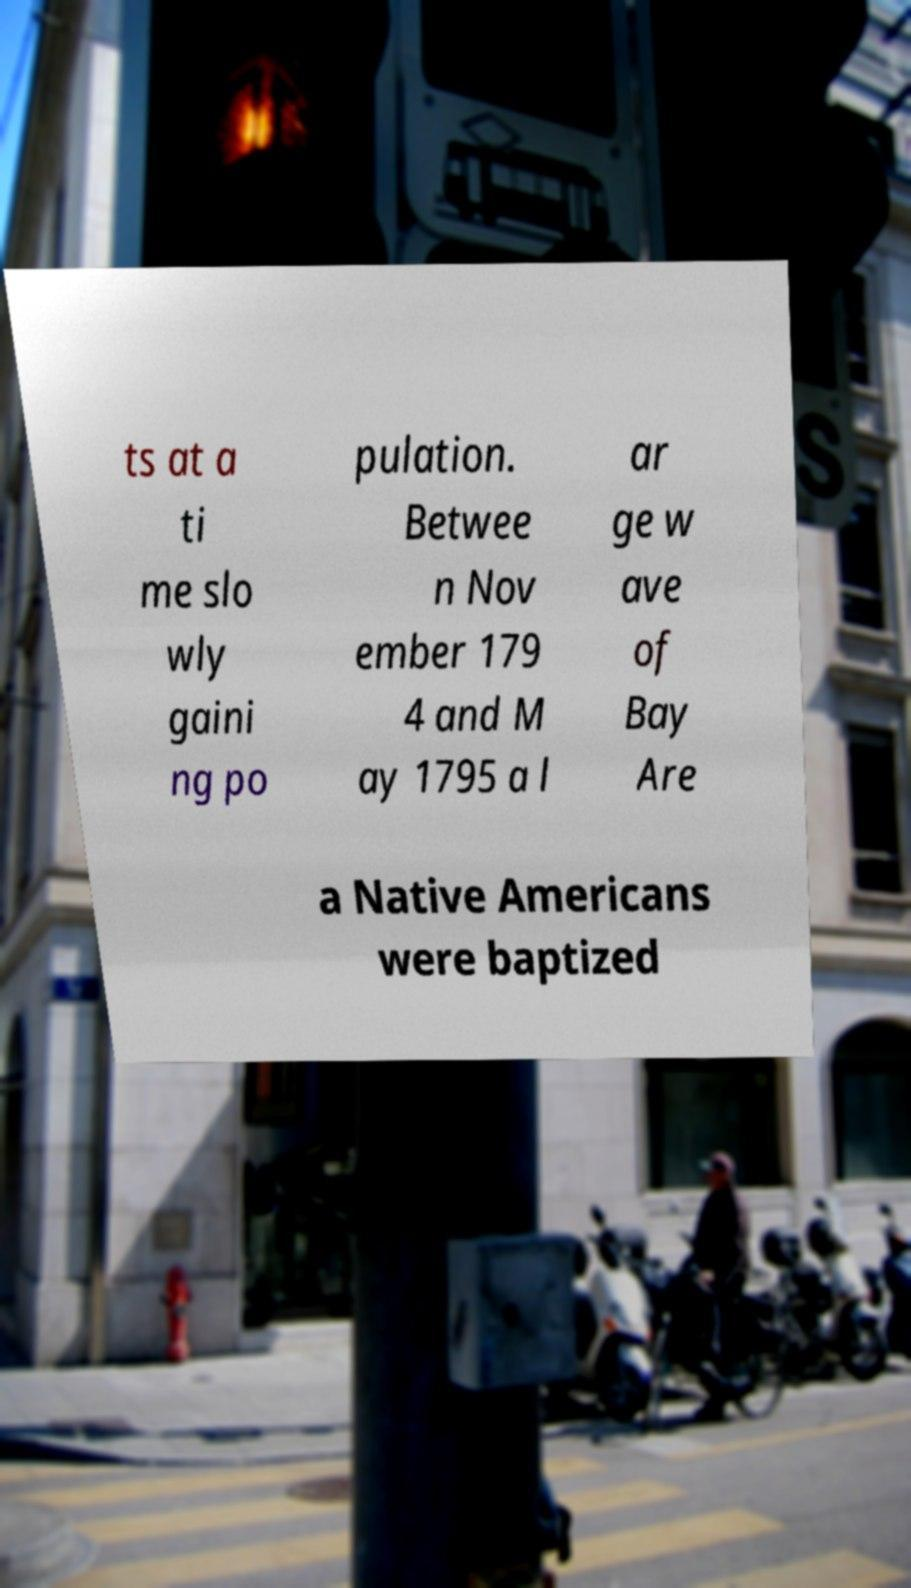What messages or text are displayed in this image? I need them in a readable, typed format. ts at a ti me slo wly gaini ng po pulation. Betwee n Nov ember 179 4 and M ay 1795 a l ar ge w ave of Bay Are a Native Americans were baptized 